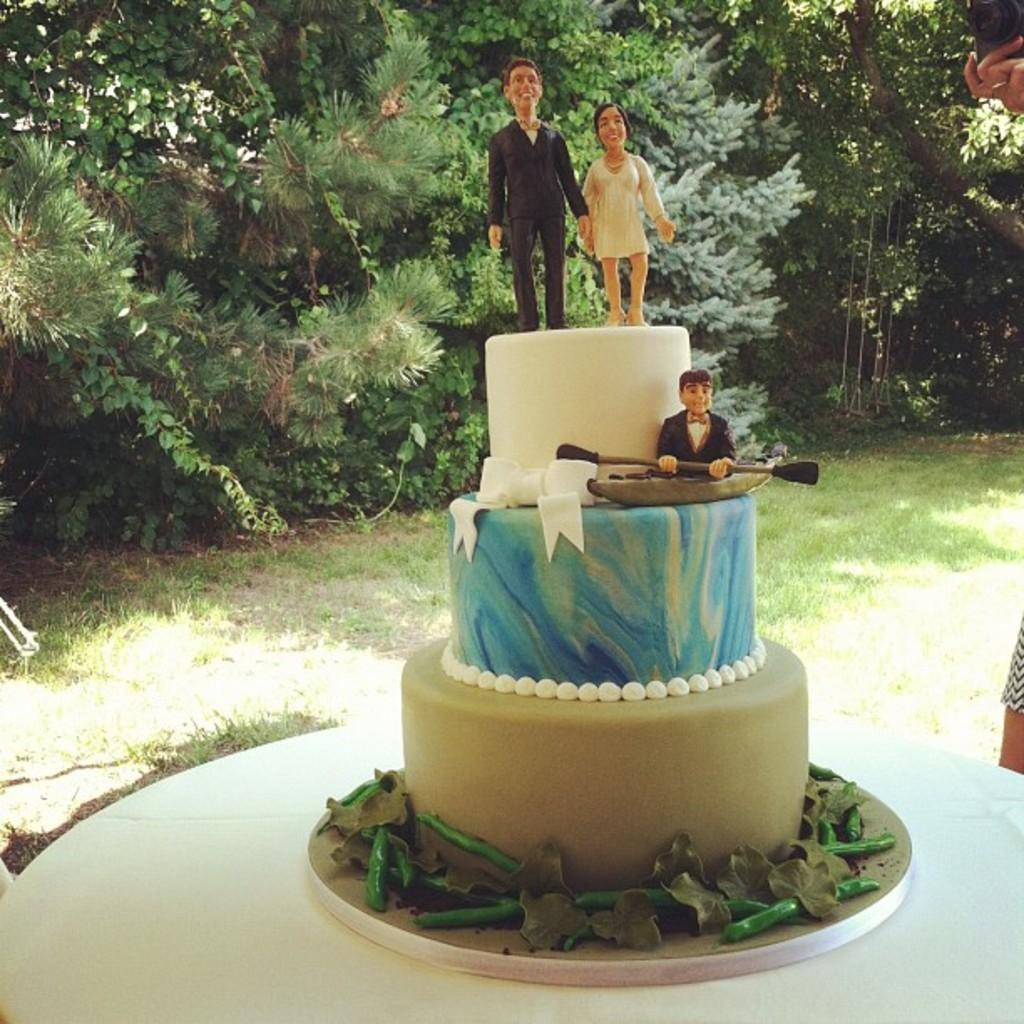What is on the table in the image? There is a cake with statues on the table. What can be seen in the background of the image? There are trees and grass visible in the background of the image. What type of knowledge is required to understand the cake's structure in the image? There is no specific knowledge required to understand the cake's structure in the image; it is a visual representation that can be observed directly. 